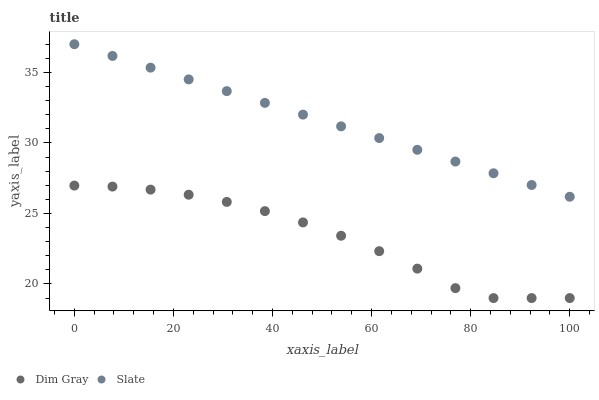Does Dim Gray have the minimum area under the curve?
Answer yes or no. Yes. Does Slate have the maximum area under the curve?
Answer yes or no. Yes. Does Dim Gray have the maximum area under the curve?
Answer yes or no. No. Is Slate the smoothest?
Answer yes or no. Yes. Is Dim Gray the roughest?
Answer yes or no. Yes. Is Dim Gray the smoothest?
Answer yes or no. No. Does Dim Gray have the lowest value?
Answer yes or no. Yes. Does Slate have the highest value?
Answer yes or no. Yes. Does Dim Gray have the highest value?
Answer yes or no. No. Is Dim Gray less than Slate?
Answer yes or no. Yes. Is Slate greater than Dim Gray?
Answer yes or no. Yes. Does Dim Gray intersect Slate?
Answer yes or no. No. 